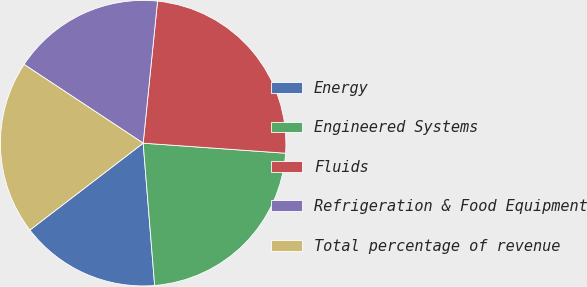Convert chart to OTSL. <chart><loc_0><loc_0><loc_500><loc_500><pie_chart><fcel>Energy<fcel>Engineered Systems<fcel>Fluids<fcel>Refrigeration & Food Equipment<fcel>Total percentage of revenue<nl><fcel>15.87%<fcel>22.6%<fcel>24.52%<fcel>17.31%<fcel>19.71%<nl></chart> 